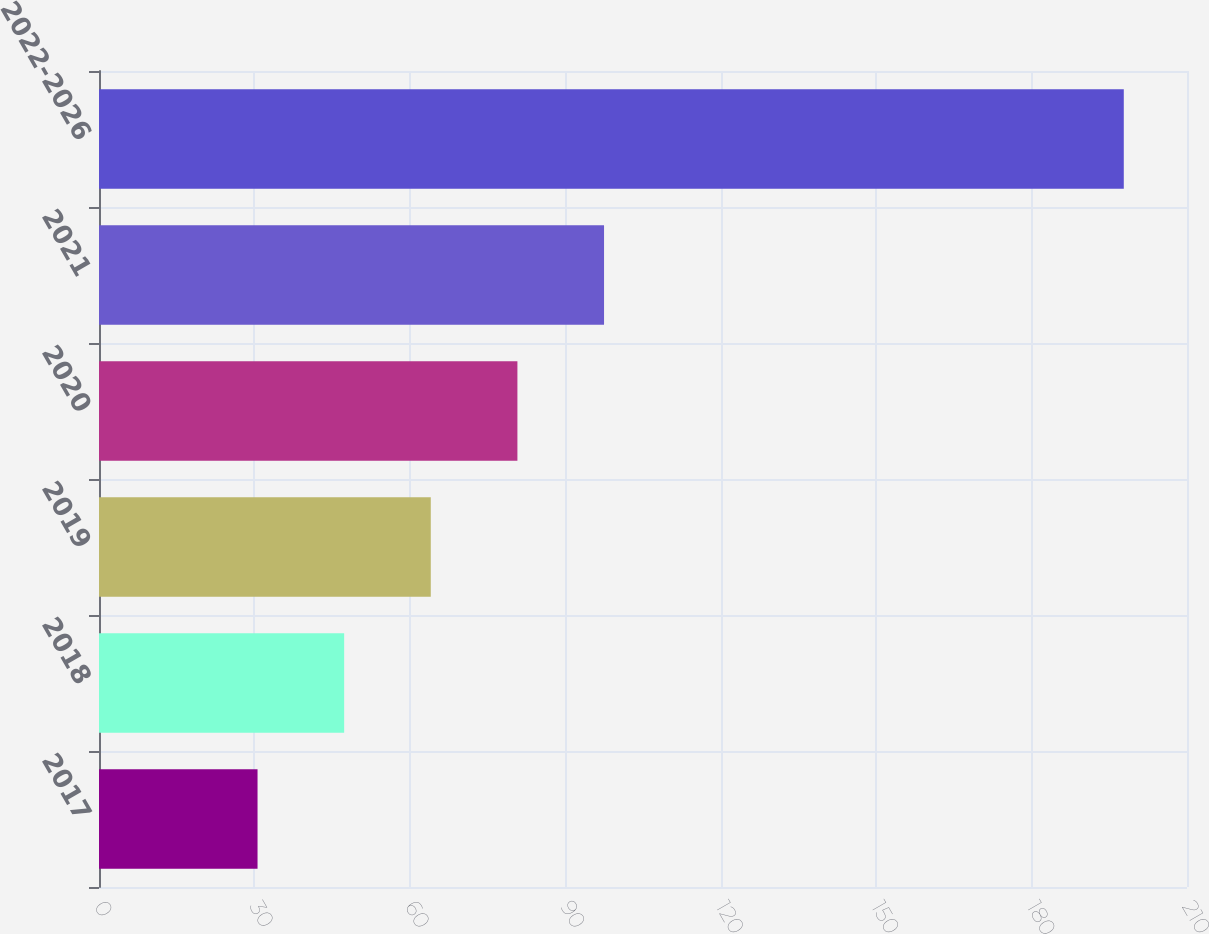Convert chart. <chart><loc_0><loc_0><loc_500><loc_500><bar_chart><fcel>2017<fcel>2018<fcel>2019<fcel>2020<fcel>2021<fcel>2022-2026<nl><fcel>30.6<fcel>47.32<fcel>64.04<fcel>80.76<fcel>97.48<fcel>197.8<nl></chart> 